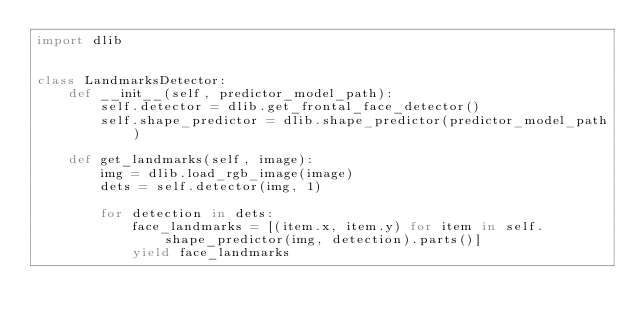Convert code to text. <code><loc_0><loc_0><loc_500><loc_500><_Python_>import dlib


class LandmarksDetector:
    def __init__(self, predictor_model_path):
        self.detector = dlib.get_frontal_face_detector()
        self.shape_predictor = dlib.shape_predictor(predictor_model_path)

    def get_landmarks(self, image):
        img = dlib.load_rgb_image(image)
        dets = self.detector(img, 1)

        for detection in dets:
            face_landmarks = [(item.x, item.y) for item in self.shape_predictor(img, detection).parts()]
            yield face_landmarks
</code> 